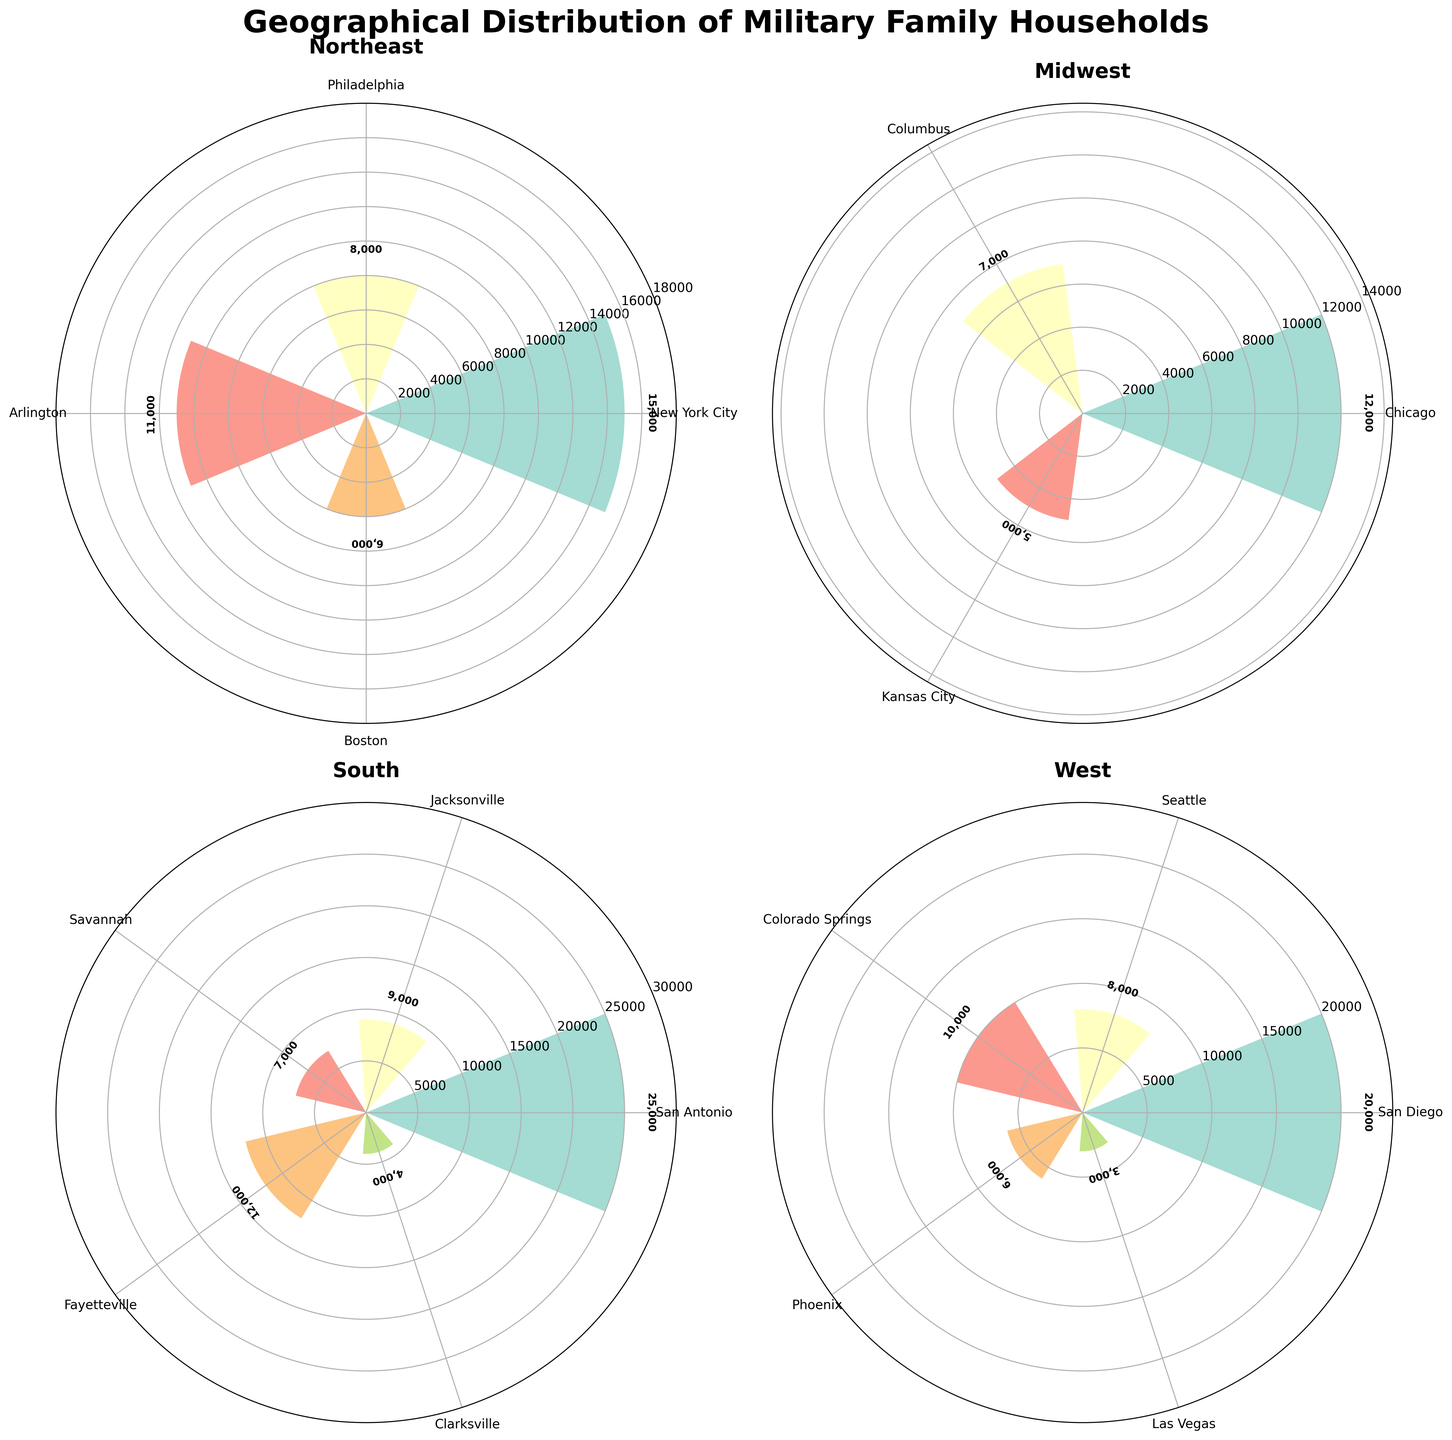What's the title of the figure? The title of the figure is positioned at the top and it reads "Geographical Distribution of Military Family Households".
Answer: Geographical Distribution of Military Family Households How many points does San Antonio have? San Antonio is represented on the south subplot of the rose chart, and the number associated with it is indicated by the height of the bar.
Answer: 25,000 Which region has the highest single value? Identify the highest bar across all four subplots, noting that the tallest bars represent the highest single values. The South subplot has the highest bar (San Antonio) at 25,000.
Answer: South Which city has the least number of military family households in the West region? In the West region subplot, identify the shortest bar, which represents the least number of military family households.
Answer: Las Vegas What's the combined number of military family households in Columbus and Chicago? In the Midwest region subplot, find the bars for Columbus and Chicago and add their corresponding numbers together: 7,000 (Columbus) + 12,000 (Chicago) = 19,000.
Answer: 19,000 Which has more military family households: Seattle in the West or Jacksonville in the South? Compare the bars for Seattle in the West subplot and Jacksonville in the South subplot. Seattle has 8,000, and Jacksonville has 9,000, so Jacksonville has more.
Answer: Jacksonville What's the difference in the number of military family households between Virginia (Arlington) and Massachusetts (Boston) in the Northeast region? In the Northeast region subplot, subtract the number for Boston from that for Arlington: 11,000 (Arlington) - 6,000 (Boston) = 5,000.
Answer: 5,000 How does the number of military family households in Colorado Springs compare to San Diego? Check the heights of the bars for Colorado Springs and San Diego in the West subplot. Colorado Springs has 10,000, and San Diego has 20,000, thus San Diego has more.
Answer: San Diego has more 